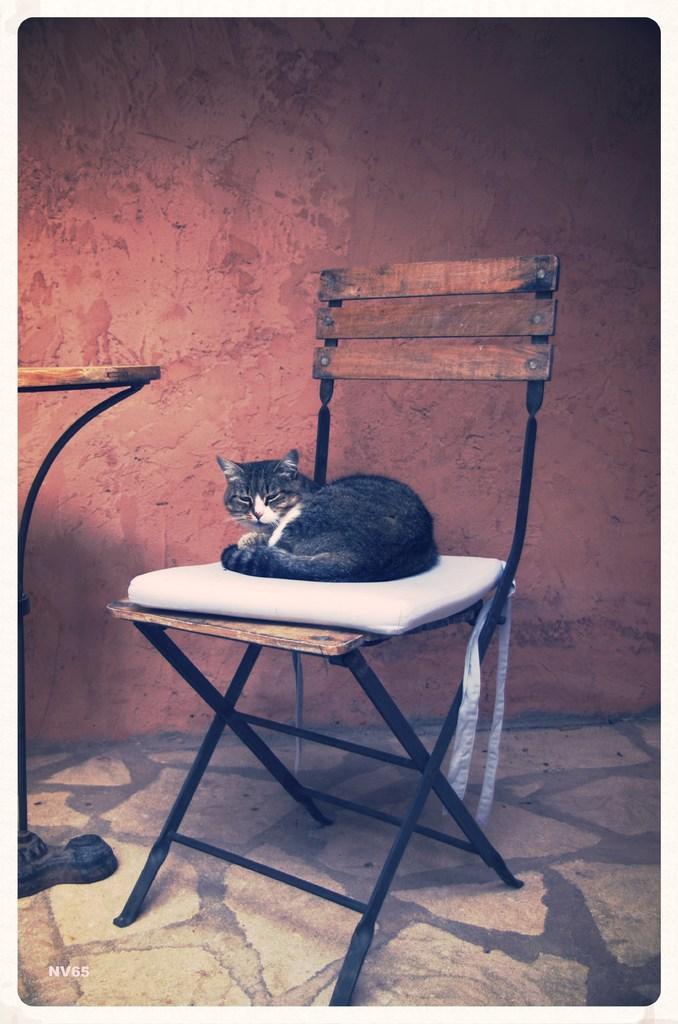Could you give a brief overview of what you see in this image? In this image I can see a chair ,on the chair I can see a pillow and on the pillow I can see a black color cat and there is a wall visible on the background. 